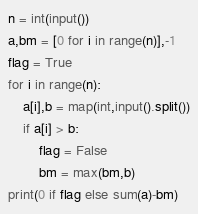Convert code to text. <code><loc_0><loc_0><loc_500><loc_500><_Python_>n = int(input())
a,bm = [0 for i in range(n)],-1
flag = True
for i in range(n):
	a[i],b = map(int,input().split())
	if a[i] > b:
		flag = False
		bm = max(bm,b)
print(0 if flag else sum(a)-bm)</code> 